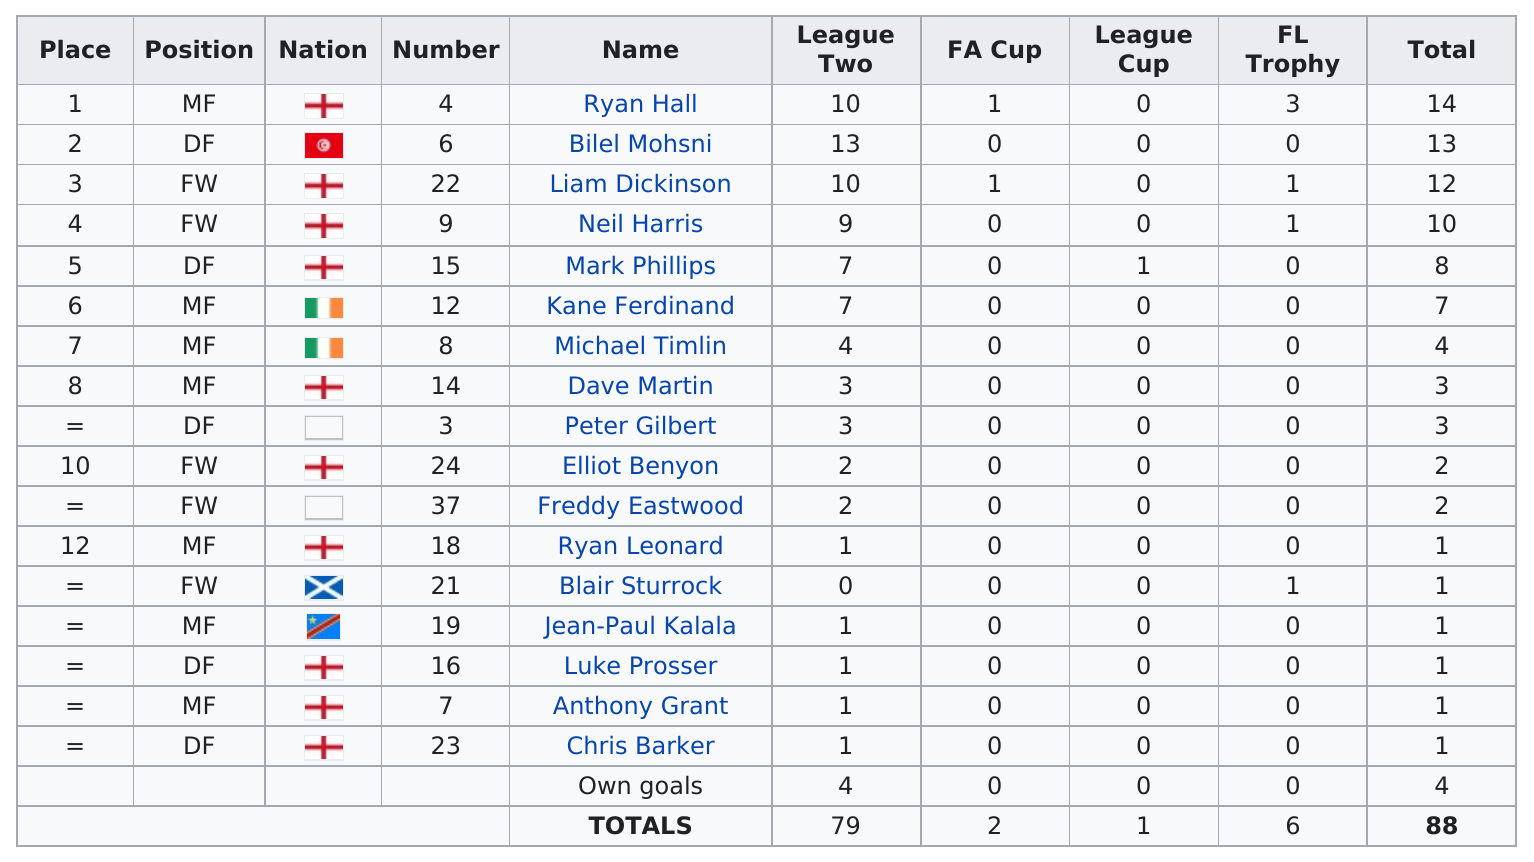Point out several critical features in this image. The names Kane, Ferdinand, and Timlin are of Irish origin, and they originate from Ireland. 10 players out of the top scorers in the chart are represented from England. Based on the average number of points scored by a given player in League 2, the average score is 4.6. Out of all the players who participated in the League Cup, a total of 1 player scored. Clint Eastwood scored two times. 